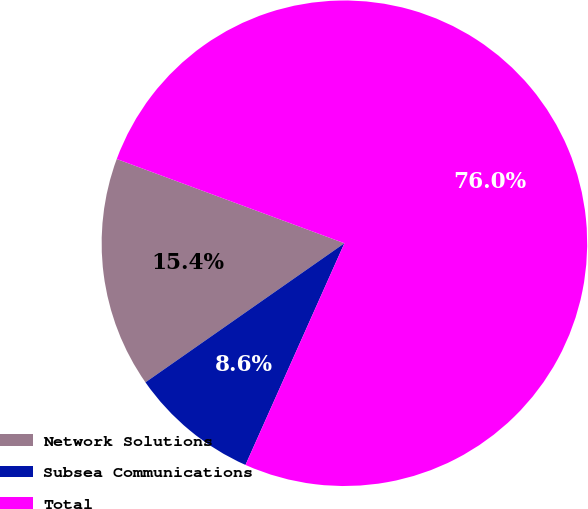<chart> <loc_0><loc_0><loc_500><loc_500><pie_chart><fcel>Network Solutions<fcel>Subsea Communications<fcel>Total<nl><fcel>15.35%<fcel>8.61%<fcel>76.04%<nl></chart> 